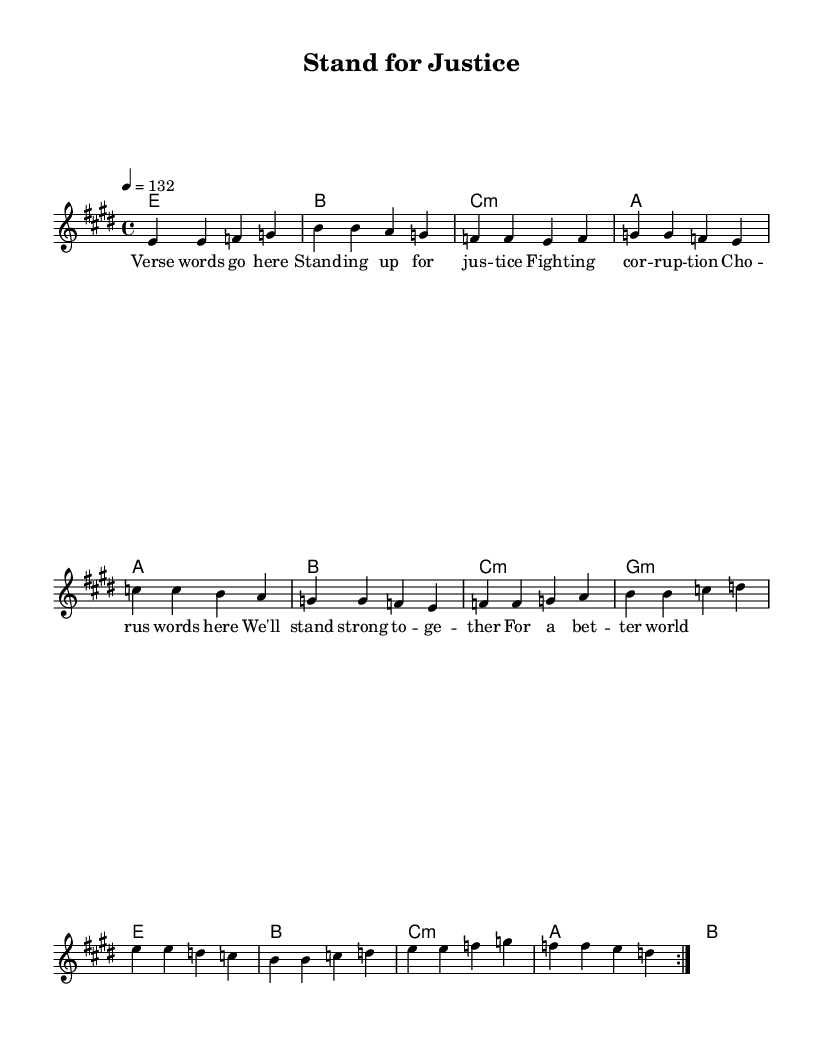What is the key signature of this music? The key signature is E major, which includes four sharps: F#, C#, G#, and D#.
Answer: E major What is the time signature of this piece? The time signature is 4/4, indicating there are four beats in each measure.
Answer: 4/4 What is the tempo of the song? The tempo is indicated as 132 beats per minute, which is relatively fast and energetic for a pop-rock song.
Answer: 132 How many measures are in the verse section? The verse is repeated twice, and within it there are four measures, resulting in a total of eight measures for this section.
Answer: 8 What is the main lyrical theme of the song? The lyrics focus on themes of justice and fighting against corruption, as indicated in both the verse and chorus.
Answer: Justice Which chord is used in the pre-chorus section? The pre-chorus includes the chords A minor, B major, C minor, and G minor, with A minor being the first chord of that section.
Answer: A minor In which part of the song does the chorus appear? The chorus appears after the pre-chorus section, serving as a climactic point in the song.
Answer: After the pre-chorus 